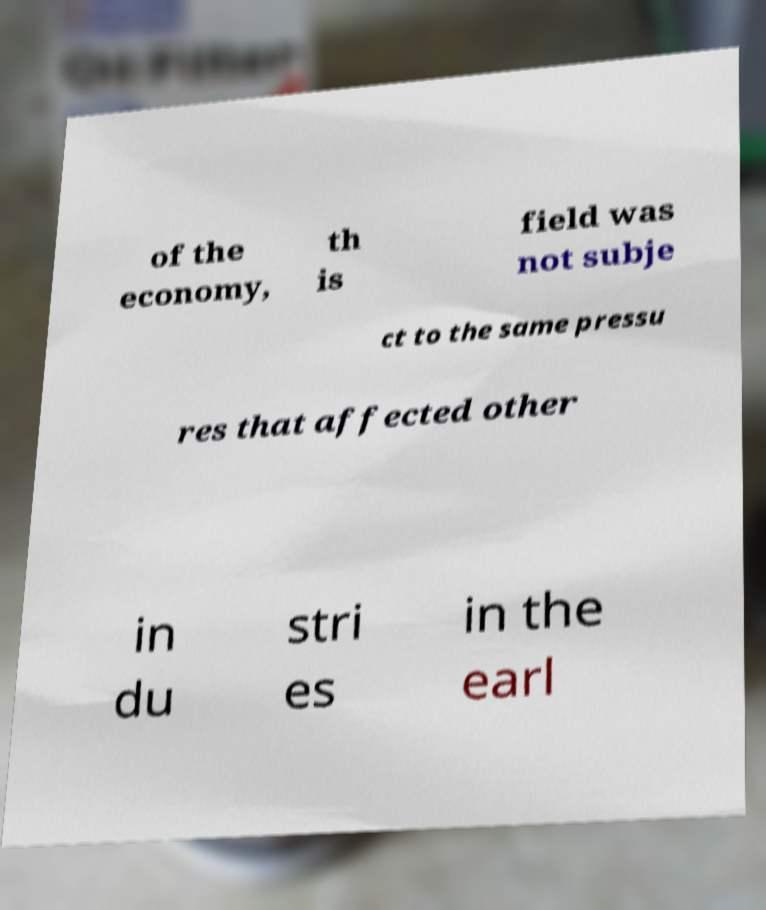Can you read and provide the text displayed in the image?This photo seems to have some interesting text. Can you extract and type it out for me? of the economy, th is field was not subje ct to the same pressu res that affected other in du stri es in the earl 